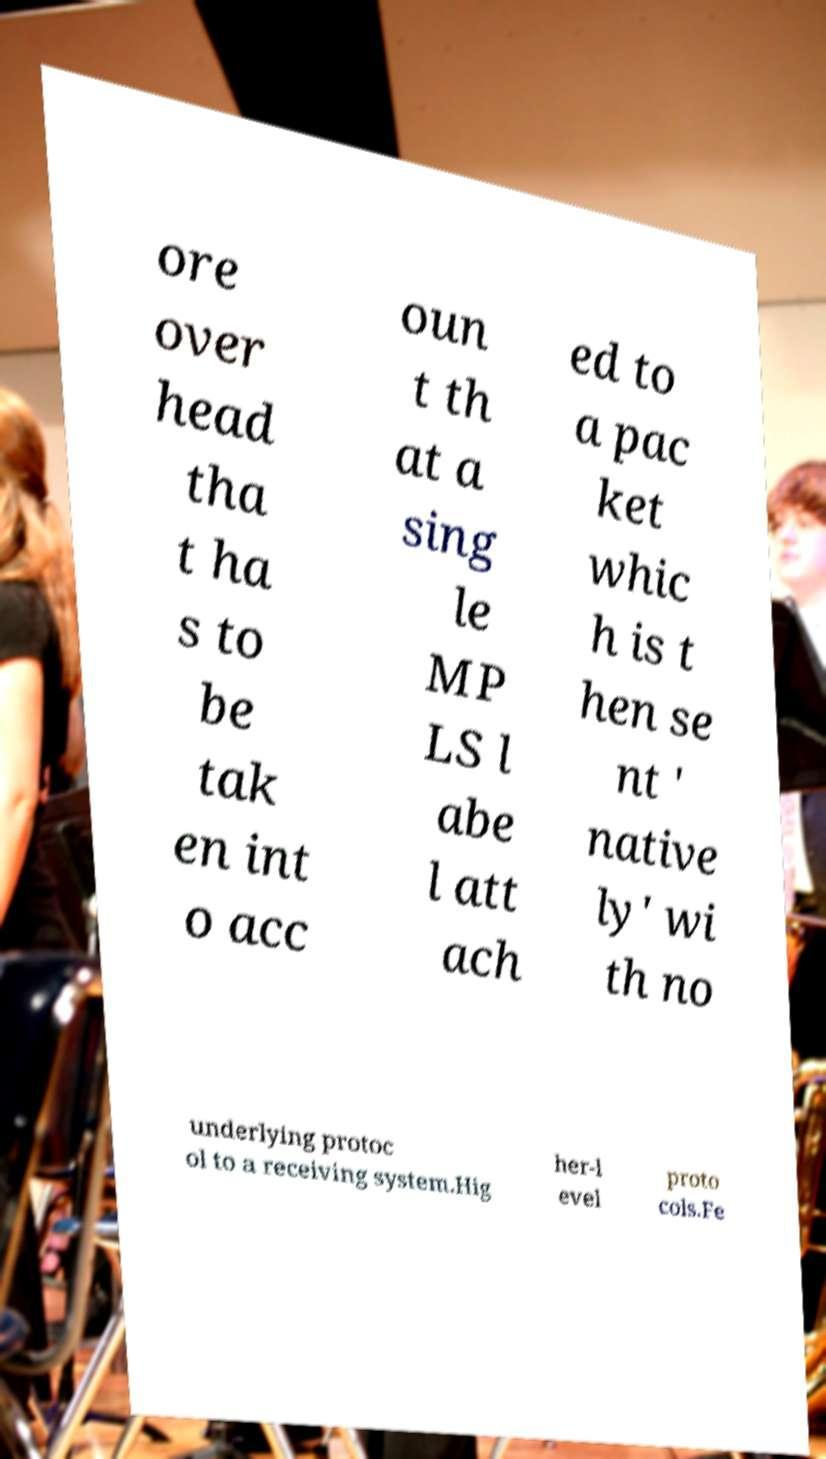Could you assist in decoding the text presented in this image and type it out clearly? ore over head tha t ha s to be tak en int o acc oun t th at a sing le MP LS l abe l att ach ed to a pac ket whic h is t hen se nt ' native ly' wi th no underlying protoc ol to a receiving system.Hig her-l evel proto cols.Fe 